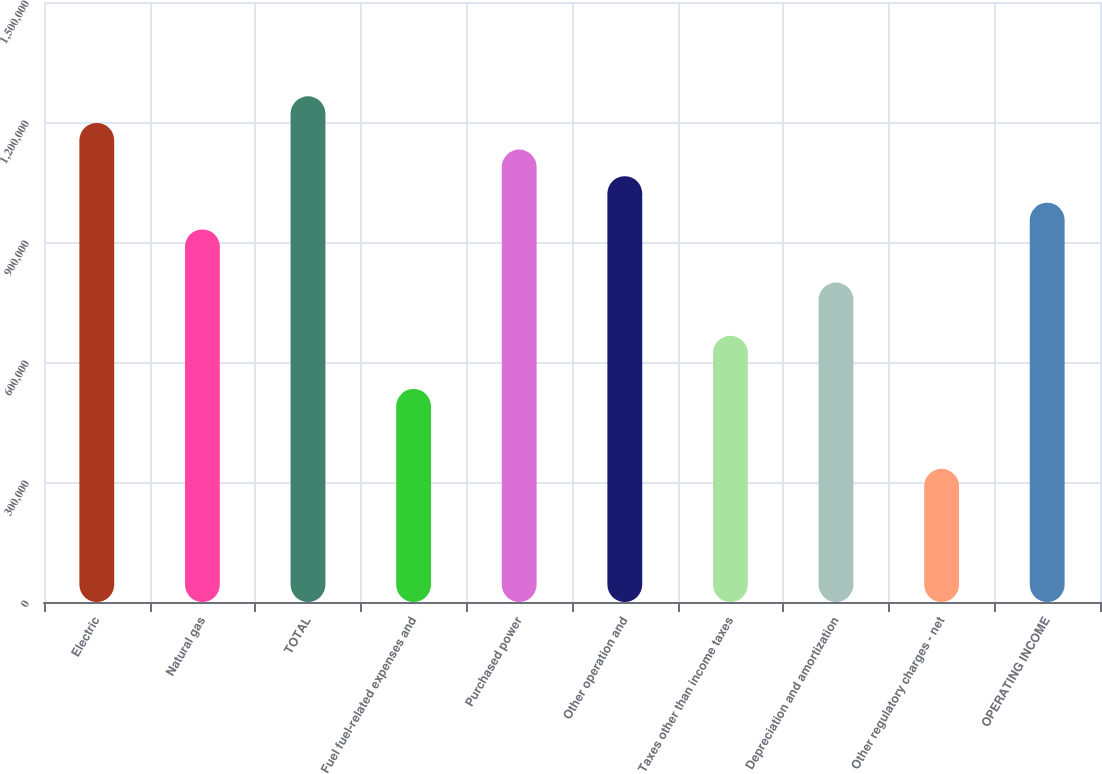<chart> <loc_0><loc_0><loc_500><loc_500><bar_chart><fcel>Electric<fcel>Natural gas<fcel>TOTAL<fcel>Fuel fuel-related expenses and<fcel>Purchased power<fcel>Other operation and<fcel>Taxes other than income taxes<fcel>Depreciation and amortization<fcel>Other regulatory charges - net<fcel>OPERATING INCOME<nl><fcel>1.19763e+06<fcel>931546<fcel>1.26415e+06<fcel>532422<fcel>1.13111e+06<fcel>1.06459e+06<fcel>665463<fcel>798504<fcel>332860<fcel>998066<nl></chart> 